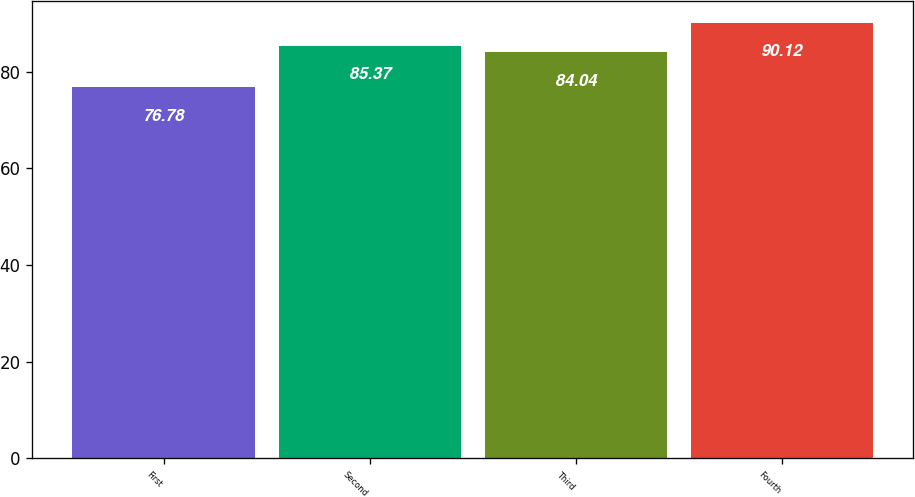Convert chart to OTSL. <chart><loc_0><loc_0><loc_500><loc_500><bar_chart><fcel>First<fcel>Second<fcel>Third<fcel>Fourth<nl><fcel>76.78<fcel>85.37<fcel>84.04<fcel>90.12<nl></chart> 